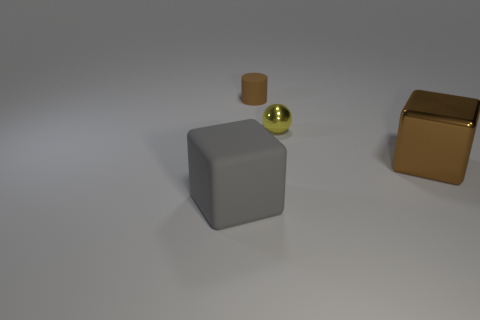What is the size of the other thing that is made of the same material as the tiny yellow object?
Offer a terse response. Large. What size is the brown metal cube?
Your answer should be compact. Large. Are the tiny yellow ball and the brown block made of the same material?
Offer a very short reply. Yes. What number of cylinders are either gray things or yellow objects?
Your answer should be very brief. 0. There is a matte thing that is in front of the cube that is behind the big gray block; what color is it?
Ensure brevity in your answer.  Gray. What size is the thing that is the same color as the small rubber cylinder?
Your answer should be very brief. Large. There is a large block right of the rubber thing in front of the big brown object; how many small brown objects are behind it?
Make the answer very short. 1. Does the big thing to the left of the large metal block have the same shape as the rubber object behind the yellow object?
Your answer should be compact. No. What number of objects are either green things or small metallic spheres?
Ensure brevity in your answer.  1. What material is the large block that is right of the rubber object that is to the left of the tiny rubber cylinder made of?
Provide a short and direct response. Metal. 